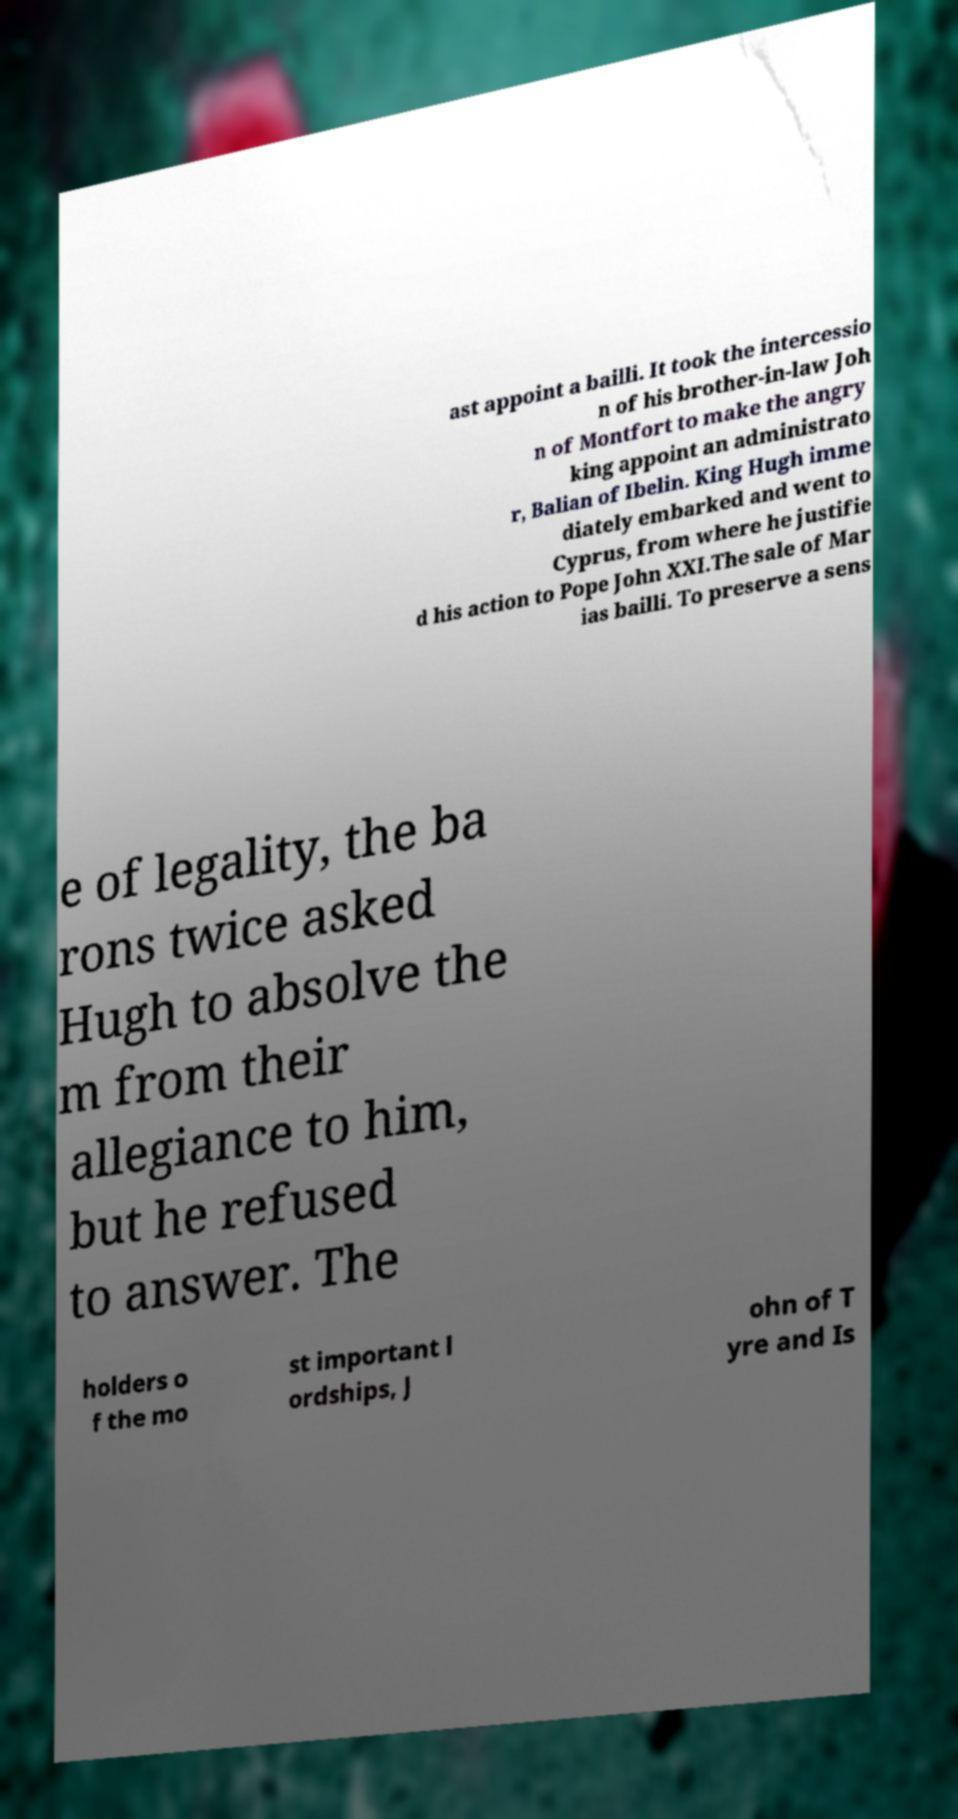Could you extract and type out the text from this image? ast appoint a bailli. It took the intercessio n of his brother-in-law Joh n of Montfort to make the angry king appoint an administrato r, Balian of Ibelin. King Hugh imme diately embarked and went to Cyprus, from where he justifie d his action to Pope John XXI.The sale of Mar ias bailli. To preserve a sens e of legality, the ba rons twice asked Hugh to absolve the m from their allegiance to him, but he refused to answer. The holders o f the mo st important l ordships, J ohn of T yre and Is 